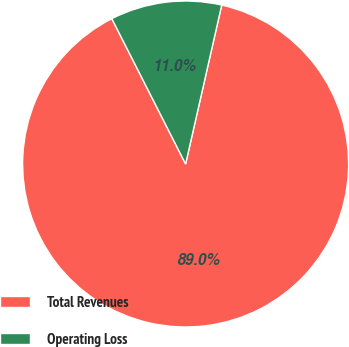<chart> <loc_0><loc_0><loc_500><loc_500><pie_chart><fcel>Total Revenues<fcel>Operating Loss<nl><fcel>88.97%<fcel>11.03%<nl></chart> 